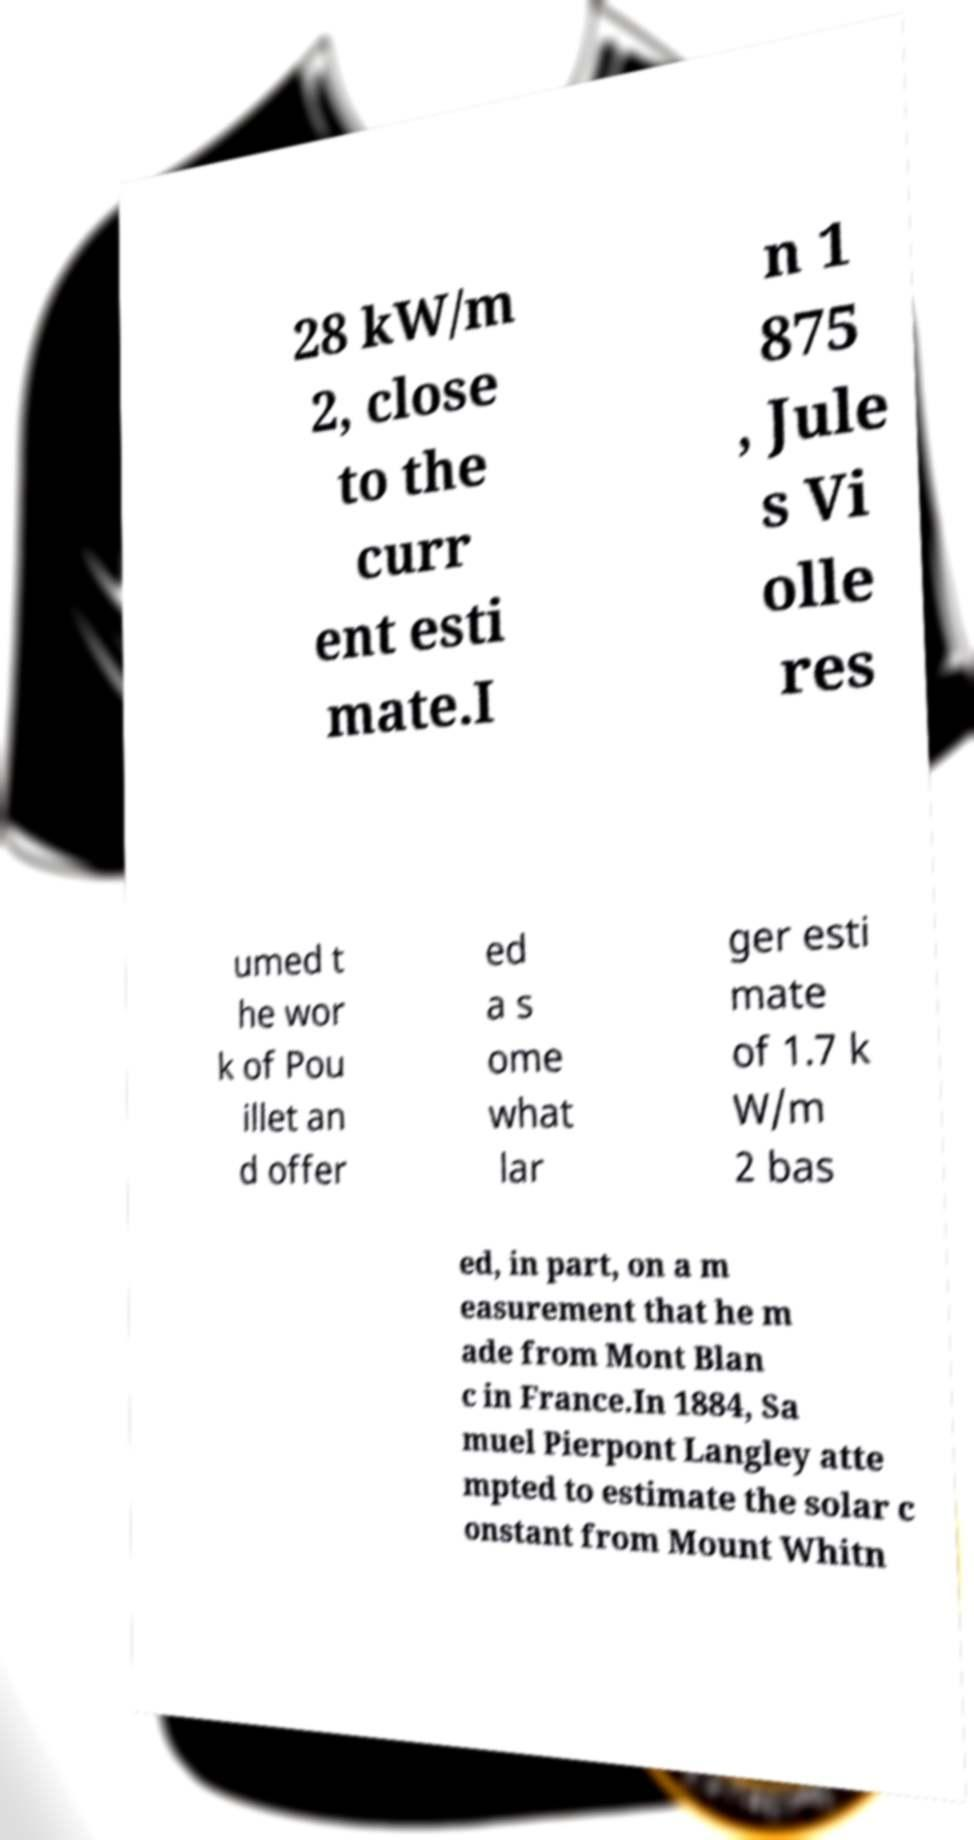Can you accurately transcribe the text from the provided image for me? 28 kW/m 2, close to the curr ent esti mate.I n 1 875 , Jule s Vi olle res umed t he wor k of Pou illet an d offer ed a s ome what lar ger esti mate of 1.7 k W/m 2 bas ed, in part, on a m easurement that he m ade from Mont Blan c in France.In 1884, Sa muel Pierpont Langley atte mpted to estimate the solar c onstant from Mount Whitn 